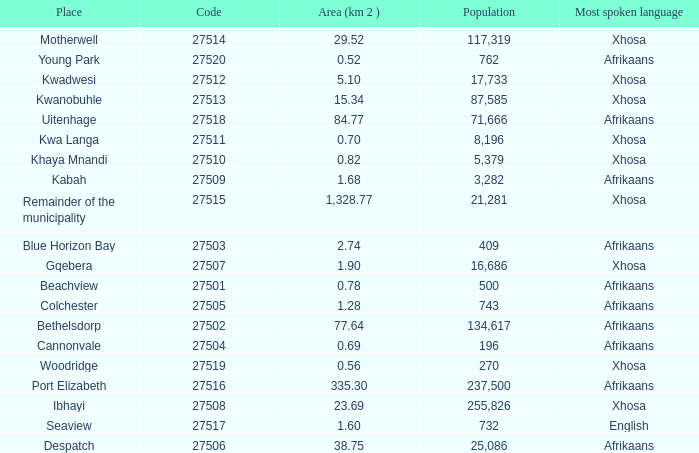Could you parse the entire table as a dict? {'header': ['Place', 'Code', 'Area (km 2 )', 'Population', 'Most spoken language'], 'rows': [['Motherwell', '27514', '29.52', '117,319', 'Xhosa'], ['Young Park', '27520', '0.52', '762', 'Afrikaans'], ['Kwadwesi', '27512', '5.10', '17,733', 'Xhosa'], ['Kwanobuhle', '27513', '15.34', '87,585', 'Xhosa'], ['Uitenhage', '27518', '84.77', '71,666', 'Afrikaans'], ['Kwa Langa', '27511', '0.70', '8,196', 'Xhosa'], ['Khaya Mnandi', '27510', '0.82', '5,379', 'Xhosa'], ['Kabah', '27509', '1.68', '3,282', 'Afrikaans'], ['Remainder of the municipality', '27515', '1,328.77', '21,281', 'Xhosa'], ['Blue Horizon Bay', '27503', '2.74', '409', 'Afrikaans'], ['Gqebera', '27507', '1.90', '16,686', 'Xhosa'], ['Beachview', '27501', '0.78', '500', 'Afrikaans'], ['Colchester', '27505', '1.28', '743', 'Afrikaans'], ['Bethelsdorp', '27502', '77.64', '134,617', 'Afrikaans'], ['Cannonvale', '27504', '0.69', '196', 'Afrikaans'], ['Woodridge', '27519', '0.56', '270', 'Xhosa'], ['Port Elizabeth', '27516', '335.30', '237,500', 'Afrikaans'], ['Ibhayi', '27508', '23.69', '255,826', 'Xhosa'], ['Seaview', '27517', '1.60', '732', 'English'], ['Despatch', '27506', '38.75', '25,086', 'Afrikaans']]} What is the total number of area listed for cannonvale with a population less than 409? 1.0. 